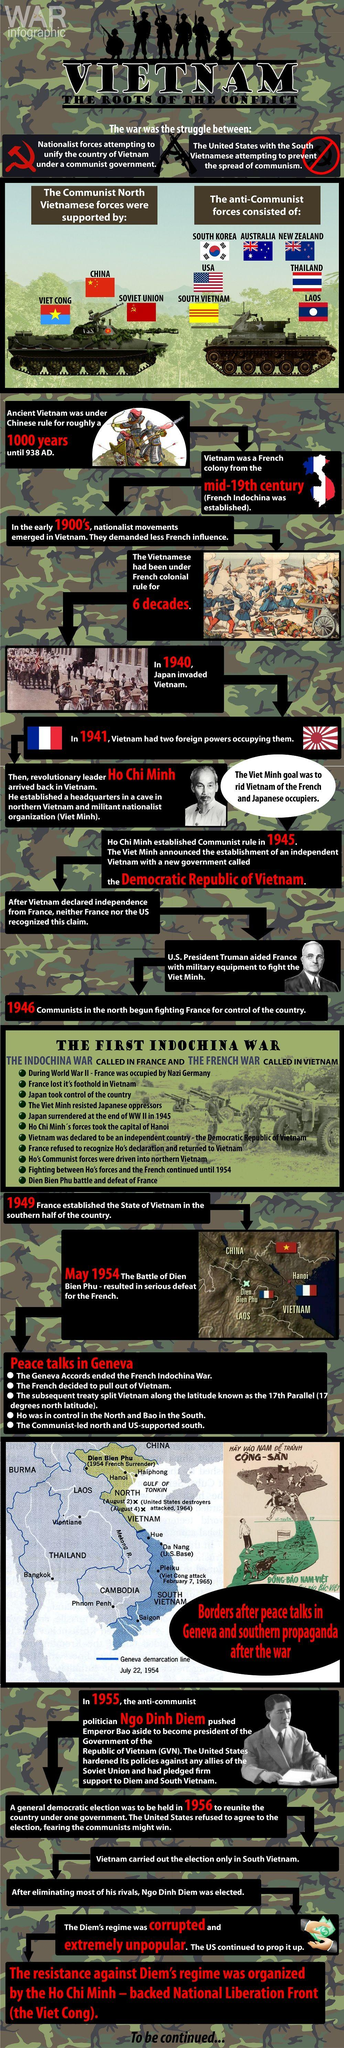Indicate a few pertinent items in this graphic. After the IndoChina War, Ho Chi Minh was the leader of North Vietnam. In 1941, Vietnam was occupied by both the French and the Japanese. France was defeated in the first Indochina War. The United States disagreed with the general democratic election in 1956. The Battle of Dien Bien Phu was the decisive conflict in which the French were finally defeated, taking place in May 1954. 